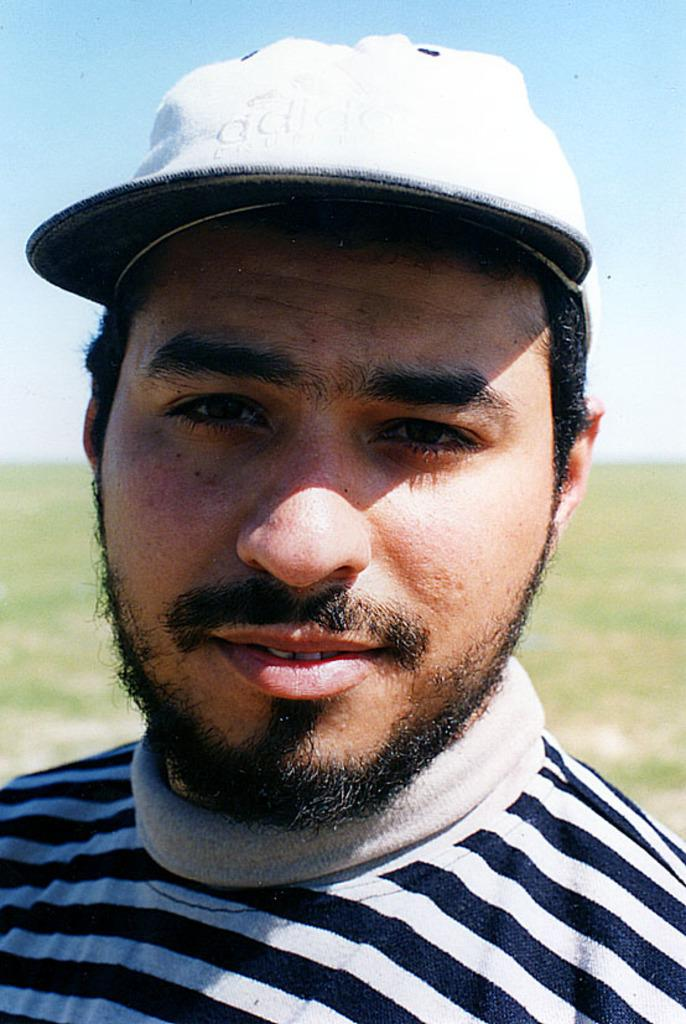Who is present in the image? There is a man in the image. What is the man wearing on his head? The man is wearing a cap. What can be seen beneath the man's feet? The ground is visible in the image. What is visible in the distance behind the man? The sky is visible in the background of the image. Can you see any deer in the image? No, there are no deer present in the image. What type of hammer is the man holding in the image? There is no hammer visible in the image; the man is only wearing a cap. 